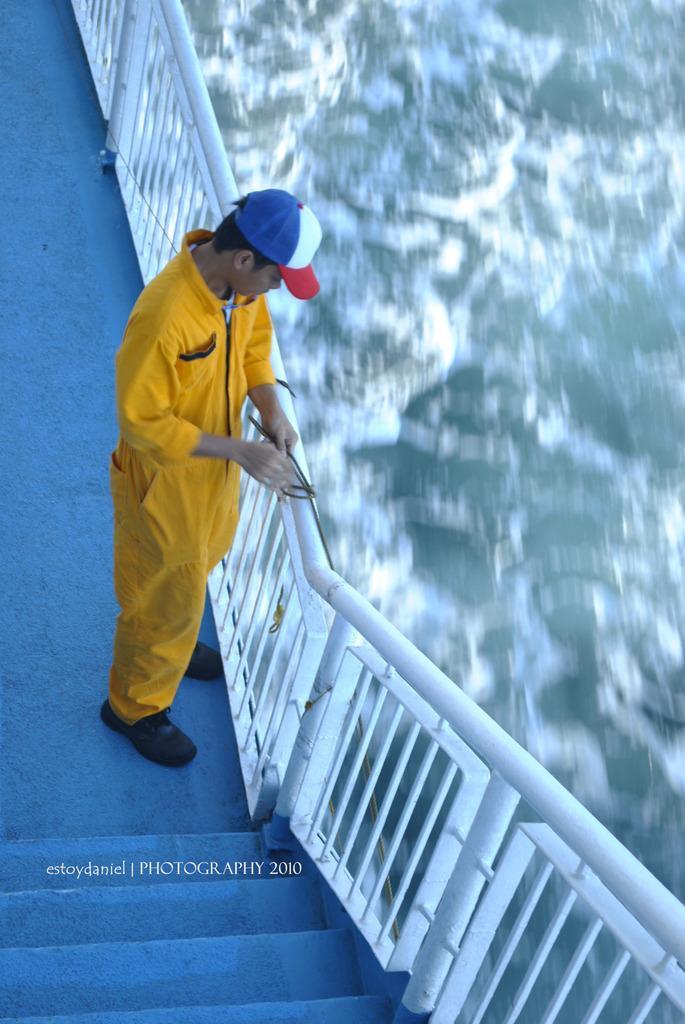In one or two sentences, can you explain what this image depicts? In the center of the image there is a person wearing yellow color uniform and a cap. There is a staircase. There is a staircase railing. To the right side of the image there is water. 